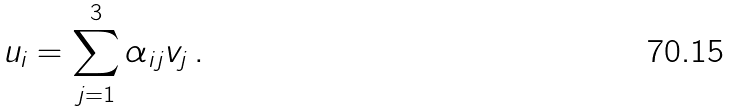<formula> <loc_0><loc_0><loc_500><loc_500>u _ { i } = \sum _ { j = 1 } ^ { 3 } \alpha _ { i j } v _ { j } \, .</formula> 